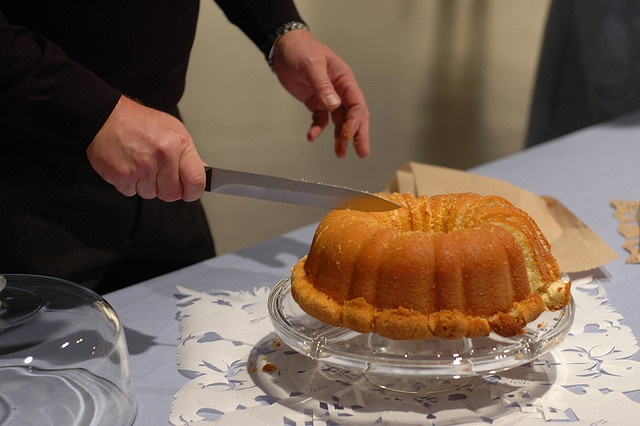Describe the objects in this image and their specific colors. I can see dining table in black, darkgray, gray, brown, and lightgray tones, people in black, brown, maroon, and gray tones, cake in black, brown, maroon, and orange tones, dining table in black, darkgray, gray, and lightgray tones, and bowl in black, gray, and darkgray tones in this image. 